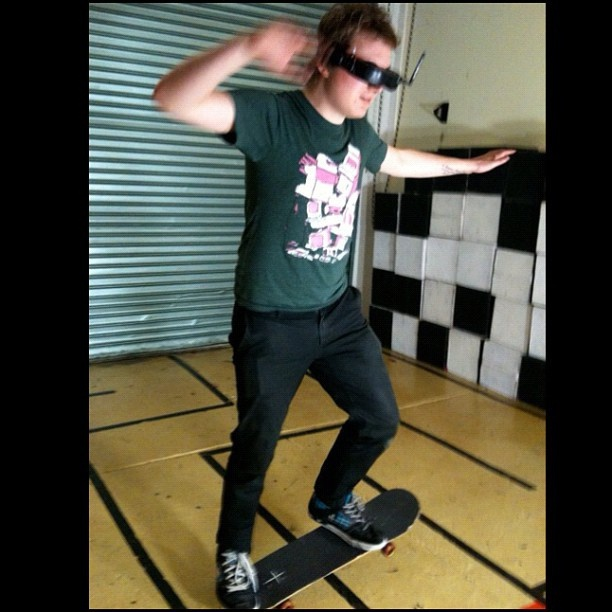Describe the objects in this image and their specific colors. I can see people in black, white, teal, and gray tones and skateboard in black, tan, and gray tones in this image. 